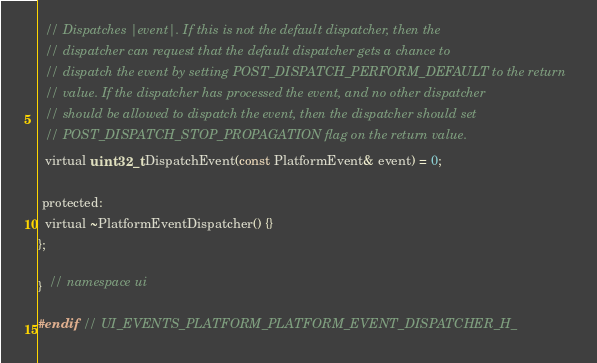<code> <loc_0><loc_0><loc_500><loc_500><_C_>  // Dispatches |event|. If this is not the default dispatcher, then the
  // dispatcher can request that the default dispatcher gets a chance to
  // dispatch the event by setting POST_DISPATCH_PERFORM_DEFAULT to the return
  // value. If the dispatcher has processed the event, and no other dispatcher
  // should be allowed to dispatch the event, then the dispatcher should set
  // POST_DISPATCH_STOP_PROPAGATION flag on the return value.
  virtual uint32_t DispatchEvent(const PlatformEvent& event) = 0;

 protected:
  virtual ~PlatformEventDispatcher() {}
};

}  // namespace ui

#endif  // UI_EVENTS_PLATFORM_PLATFORM_EVENT_DISPATCHER_H_
</code> 